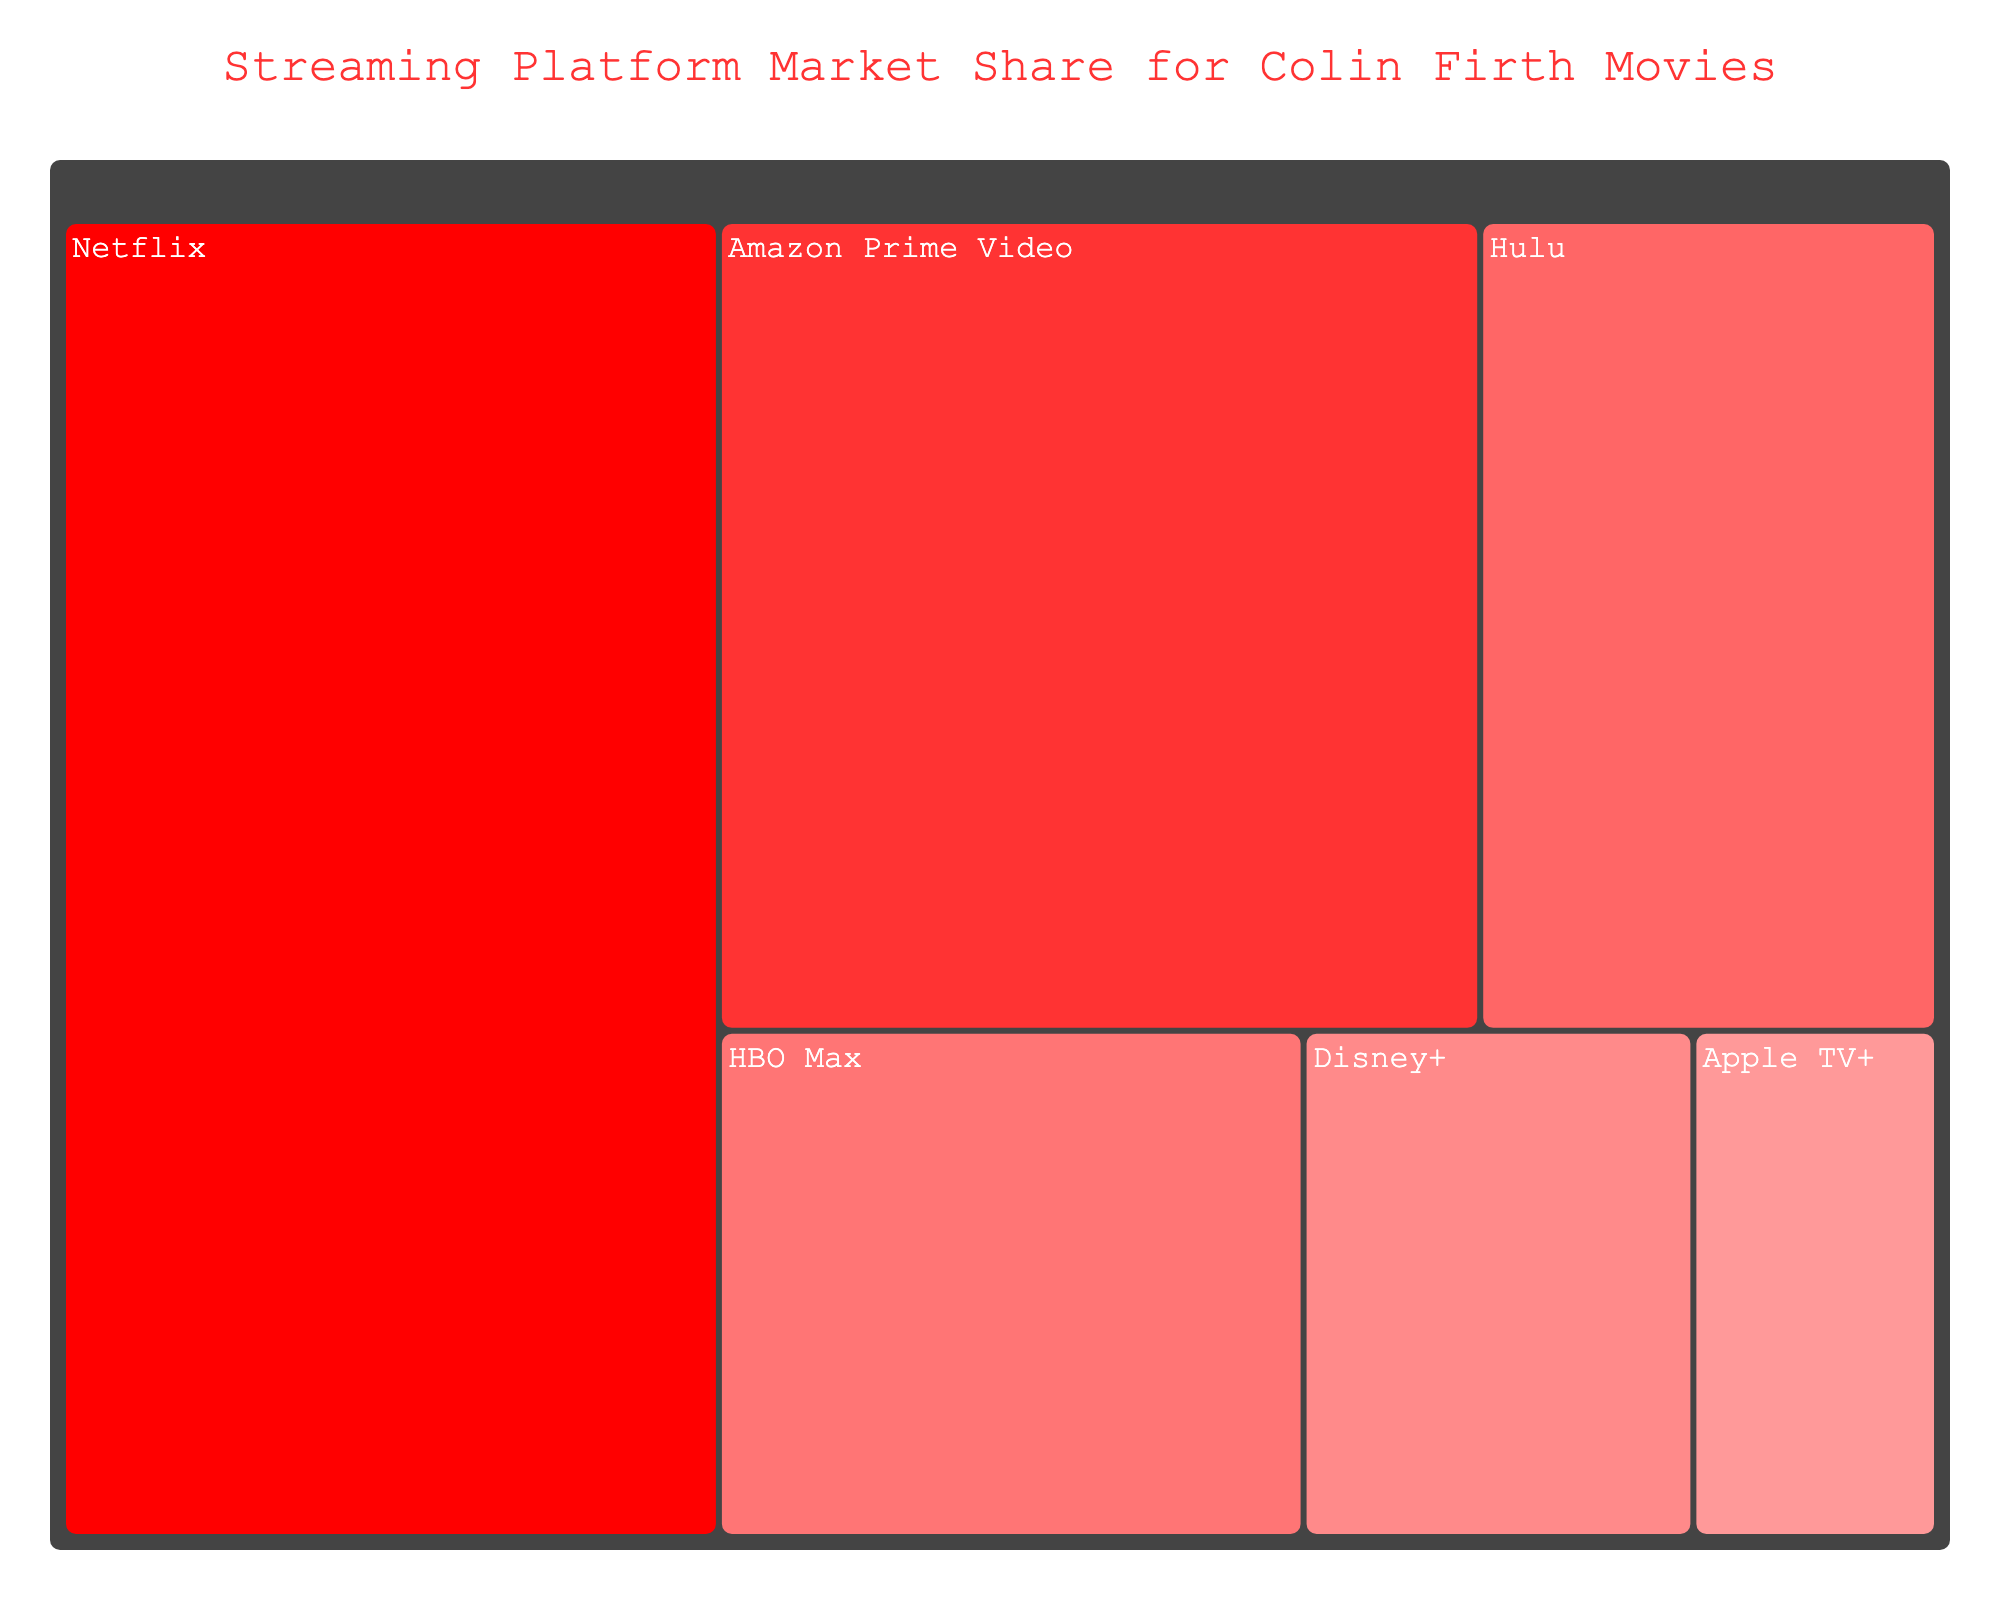What's the title of the treemap? The title is located at the top of the treemap. Observing the title text, it clearly states "Streaming Platform Market Share for Colin Firth Movies".
Answer: Streaming Platform Market Share for Colin Firth Movies Which streaming platform has the largest market share? By looking at the treemap, the largest section is labeled "Netflix" and displays a market share value of 35%.
Answer: Netflix What's the combined market share of Amazon Prime Video and Hulu? First, identify the market share for Amazon Prime Video, which is 25%, and for Hulu, which is 15%. Adding these together gives 25% + 15% = 40%.
Answer: 40% Which streaming platforms have a market share less than 10%? By observing the treemap, the platforms with less than 10% market share are Disney+ and Apple TV+, with respective market shares of 8% and 5%.
Answer: Disney+ and Apple TV+ How does the market share of HBO Max compare to Hulu? The market share for HBO Max is 12%, and for Hulu, it is 15%. By comparing these values, we see that Hulu's market share is greater than HBO Max's.
Answer: Hulu's market share is greater than HBO Max's What is the difference in market share between Netflix and Apple TV+? The market share for Netflix is 35%, and for Apple TV+, it is 5%. Subtracting these values gives 35% - 5% = 30%.
Answer: 30% Which streaming platform is closest in market share to Disney+? By examining the treemap, Disney+ has a market share of 8%. The closest in value is Apple TV+ with a market share of 5%, which is 3% different from Disney+.
Answer: Apple TV+ How many streaming platforms have a market share of over 20%? By locating the market shares on the treemap, Netflix (35%) and Amazon Prime Video (25%) are identified as the only platforms with a market share over 20%.
Answer: 2 